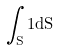<formula> <loc_0><loc_0><loc_500><loc_500>\int _ { S } 1 d S</formula> 